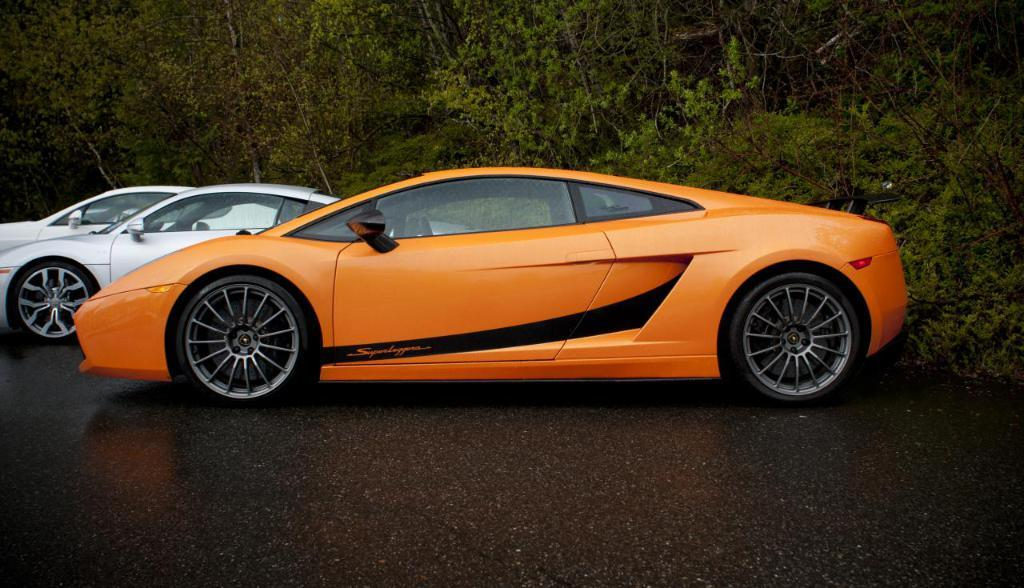What is the main subject in the center of the image? There are cars on the road in the center of the image. What can be seen in the background of the image? There are trees visible in the background of the image. What type of queen is sitting on the car in the image? There is no queen present in the image; it features cars on the road and trees in the background. 